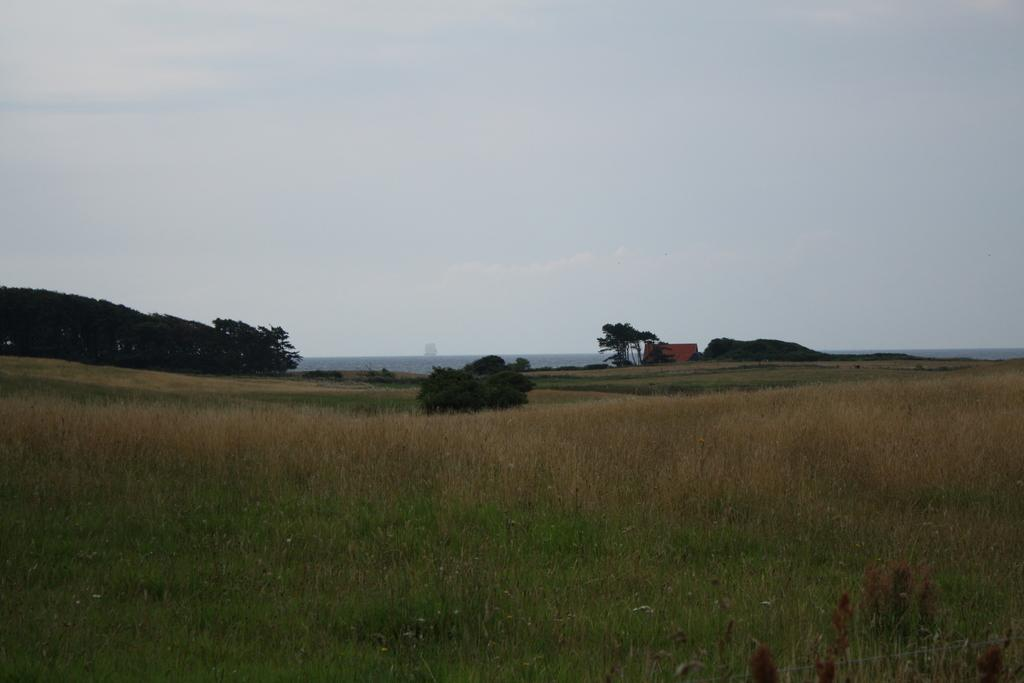What type of vegetation can be seen in the image? There is grass in the image. Are there any other plants visible in the image? Yes, there are trees in the image. What is the condition of the sky in the image? The sky is cloudy in the image. Can you see any beetles crawling on the grass in the image? There is no beetle present in the image. Is there a cobweb visible in the trees in the image? There is no cobweb present in the image. 